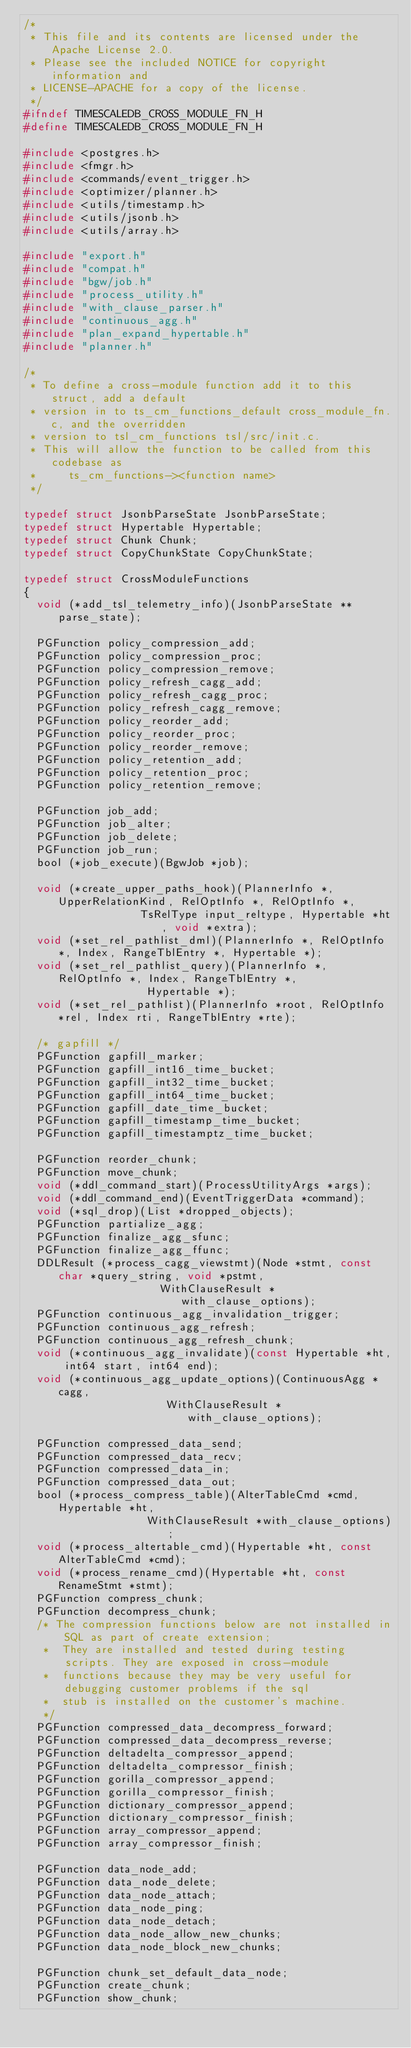Convert code to text. <code><loc_0><loc_0><loc_500><loc_500><_C_>/*
 * This file and its contents are licensed under the Apache License 2.0.
 * Please see the included NOTICE for copyright information and
 * LICENSE-APACHE for a copy of the license.
 */
#ifndef TIMESCALEDB_CROSS_MODULE_FN_H
#define TIMESCALEDB_CROSS_MODULE_FN_H

#include <postgres.h>
#include <fmgr.h>
#include <commands/event_trigger.h>
#include <optimizer/planner.h>
#include <utils/timestamp.h>
#include <utils/jsonb.h>
#include <utils/array.h>

#include "export.h"
#include "compat.h"
#include "bgw/job.h"
#include "process_utility.h"
#include "with_clause_parser.h"
#include "continuous_agg.h"
#include "plan_expand_hypertable.h"
#include "planner.h"

/*
 * To define a cross-module function add it to this struct, add a default
 * version in to ts_cm_functions_default cross_module_fn.c, and the overridden
 * version to tsl_cm_functions tsl/src/init.c.
 * This will allow the function to be called from this codebase as
 *     ts_cm_functions-><function name>
 */

typedef struct JsonbParseState JsonbParseState;
typedef struct Hypertable Hypertable;
typedef struct Chunk Chunk;
typedef struct CopyChunkState CopyChunkState;

typedef struct CrossModuleFunctions
{
	void (*add_tsl_telemetry_info)(JsonbParseState **parse_state);

	PGFunction policy_compression_add;
	PGFunction policy_compression_proc;
	PGFunction policy_compression_remove;
	PGFunction policy_refresh_cagg_add;
	PGFunction policy_refresh_cagg_proc;
	PGFunction policy_refresh_cagg_remove;
	PGFunction policy_reorder_add;
	PGFunction policy_reorder_proc;
	PGFunction policy_reorder_remove;
	PGFunction policy_retention_add;
	PGFunction policy_retention_proc;
	PGFunction policy_retention_remove;

	PGFunction job_add;
	PGFunction job_alter;
	PGFunction job_delete;
	PGFunction job_run;
	bool (*job_execute)(BgwJob *job);

	void (*create_upper_paths_hook)(PlannerInfo *, UpperRelationKind, RelOptInfo *, RelOptInfo *,
									TsRelType input_reltype, Hypertable *ht, void *extra);
	void (*set_rel_pathlist_dml)(PlannerInfo *, RelOptInfo *, Index, RangeTblEntry *, Hypertable *);
	void (*set_rel_pathlist_query)(PlannerInfo *, RelOptInfo *, Index, RangeTblEntry *,
								   Hypertable *);
	void (*set_rel_pathlist)(PlannerInfo *root, RelOptInfo *rel, Index rti, RangeTblEntry *rte);

	/* gapfill */
	PGFunction gapfill_marker;
	PGFunction gapfill_int16_time_bucket;
	PGFunction gapfill_int32_time_bucket;
	PGFunction gapfill_int64_time_bucket;
	PGFunction gapfill_date_time_bucket;
	PGFunction gapfill_timestamp_time_bucket;
	PGFunction gapfill_timestamptz_time_bucket;

	PGFunction reorder_chunk;
	PGFunction move_chunk;
	void (*ddl_command_start)(ProcessUtilityArgs *args);
	void (*ddl_command_end)(EventTriggerData *command);
	void (*sql_drop)(List *dropped_objects);
	PGFunction partialize_agg;
	PGFunction finalize_agg_sfunc;
	PGFunction finalize_agg_ffunc;
	DDLResult (*process_cagg_viewstmt)(Node *stmt, const char *query_string, void *pstmt,
									   WithClauseResult *with_clause_options);
	PGFunction continuous_agg_invalidation_trigger;
	PGFunction continuous_agg_refresh;
	PGFunction continuous_agg_refresh_chunk;
	void (*continuous_agg_invalidate)(const Hypertable *ht, int64 start, int64 end);
	void (*continuous_agg_update_options)(ContinuousAgg *cagg,
										  WithClauseResult *with_clause_options);

	PGFunction compressed_data_send;
	PGFunction compressed_data_recv;
	PGFunction compressed_data_in;
	PGFunction compressed_data_out;
	bool (*process_compress_table)(AlterTableCmd *cmd, Hypertable *ht,
								   WithClauseResult *with_clause_options);
	void (*process_altertable_cmd)(Hypertable *ht, const AlterTableCmd *cmd);
	void (*process_rename_cmd)(Hypertable *ht, const RenameStmt *stmt);
	PGFunction compress_chunk;
	PGFunction decompress_chunk;
	/* The compression functions below are not installed in SQL as part of create extension;
	 *  They are installed and tested during testing scripts. They are exposed in cross-module
	 *  functions because they may be very useful for debugging customer problems if the sql
	 *  stub is installed on the customer's machine.
	 */
	PGFunction compressed_data_decompress_forward;
	PGFunction compressed_data_decompress_reverse;
	PGFunction deltadelta_compressor_append;
	PGFunction deltadelta_compressor_finish;
	PGFunction gorilla_compressor_append;
	PGFunction gorilla_compressor_finish;
	PGFunction dictionary_compressor_append;
	PGFunction dictionary_compressor_finish;
	PGFunction array_compressor_append;
	PGFunction array_compressor_finish;

	PGFunction data_node_add;
	PGFunction data_node_delete;
	PGFunction data_node_attach;
	PGFunction data_node_ping;
	PGFunction data_node_detach;
	PGFunction data_node_allow_new_chunks;
	PGFunction data_node_block_new_chunks;

	PGFunction chunk_set_default_data_node;
	PGFunction create_chunk;
	PGFunction show_chunk;</code> 